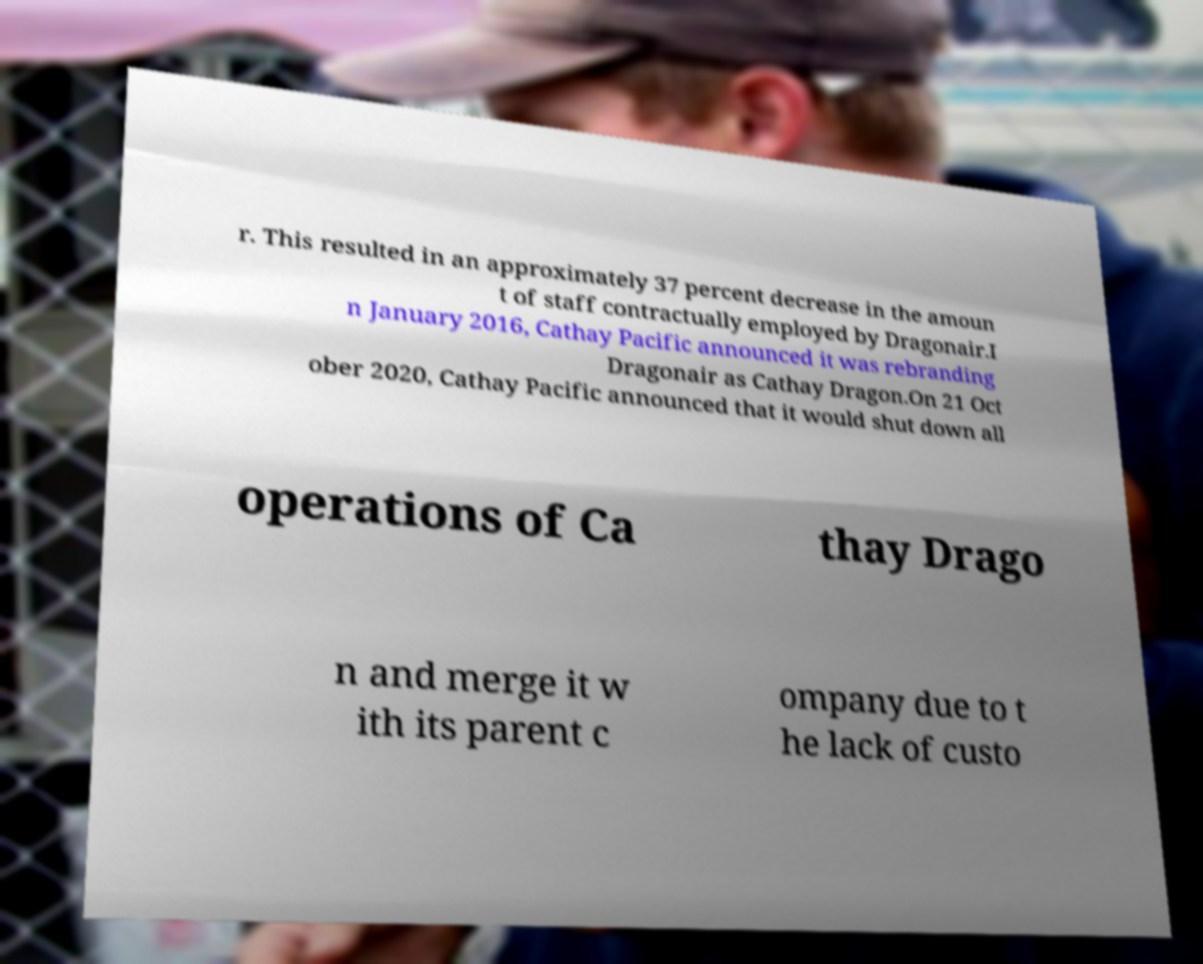Please read and relay the text visible in this image. What does it say? r. This resulted in an approximately 37 percent decrease in the amoun t of staff contractually employed by Dragonair.I n January 2016, Cathay Pacific announced it was rebranding Dragonair as Cathay Dragon.On 21 Oct ober 2020, Cathay Pacific announced that it would shut down all operations of Ca thay Drago n and merge it w ith its parent c ompany due to t he lack of custo 